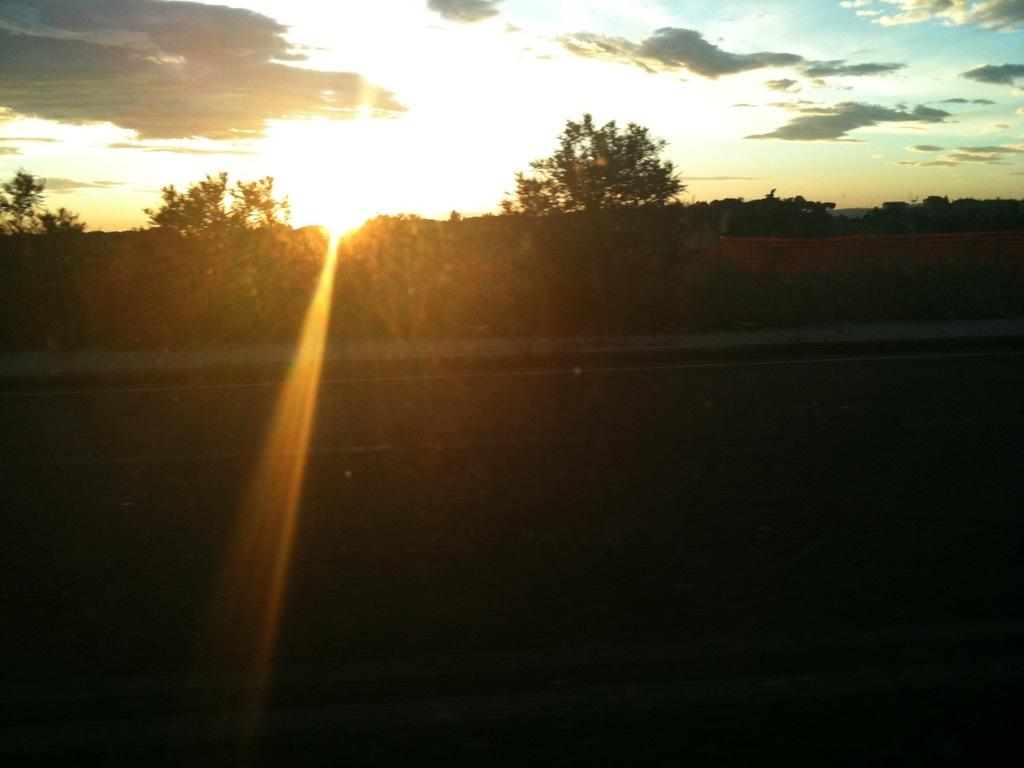What type of vegetation can be seen in the image? There are trees in the image. What part of the natural environment is visible in the image? The sky is visible in the image. What can be seen in the sky? There are clouds in the sky. What is the source of light in the image? Sunshine is present in the image. What route are the planes taking in the image? There are no planes present in the image, so it is not possible to determine the route they might be taking. 